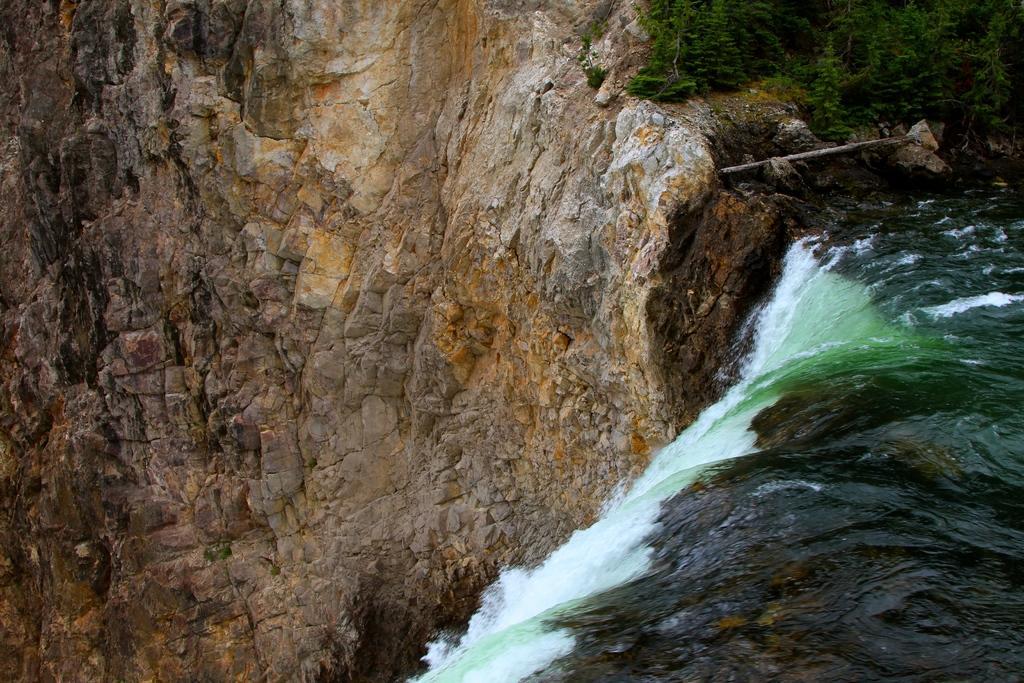In one or two sentences, can you explain what this image depicts? In this picture we can see a waterfall on the right side. There are planets visible in the top right. It looks like a rock hill on the left side. 